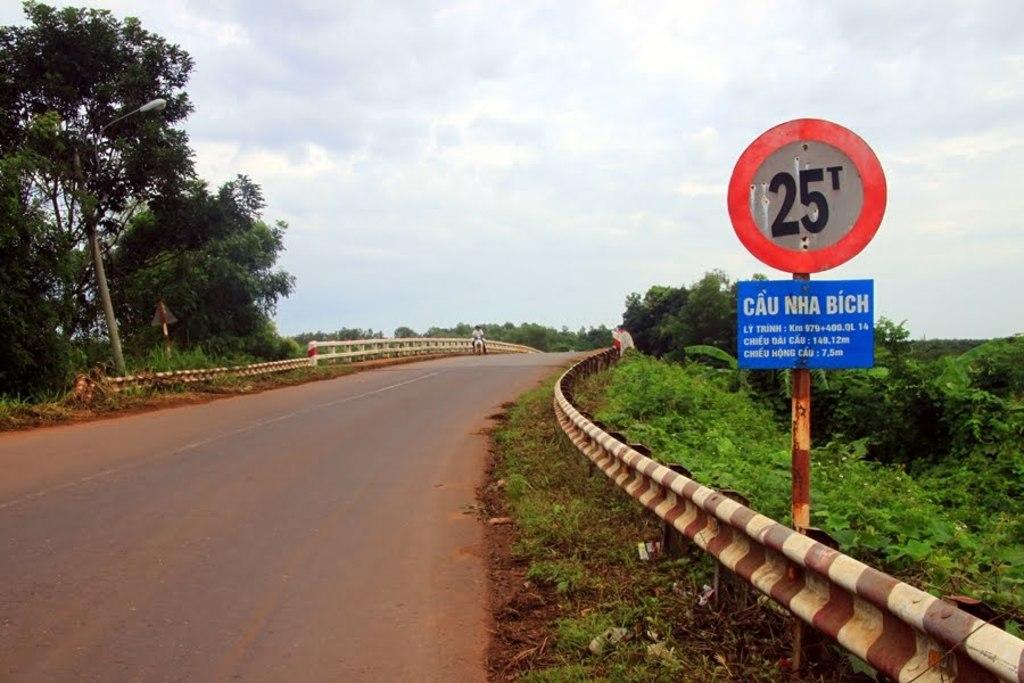What number is on the sign?
Ensure brevity in your answer.  25. 